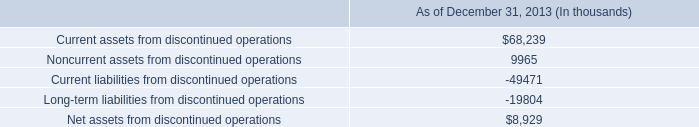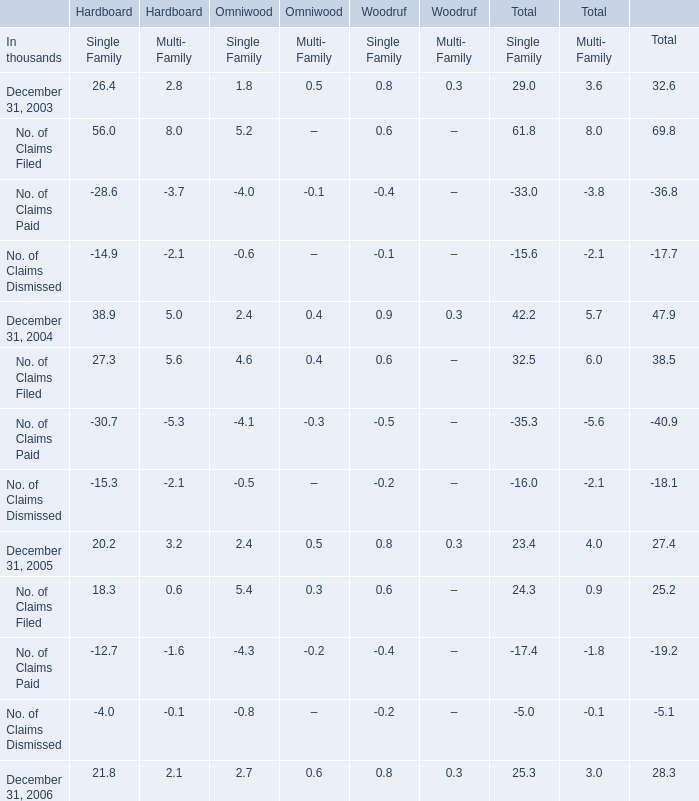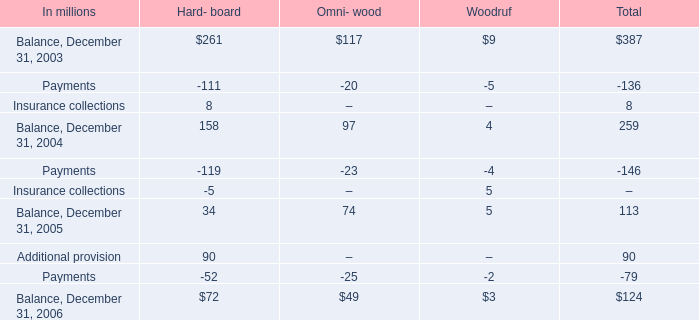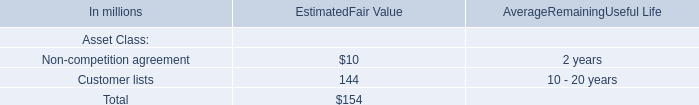What is the growing rate of No. of Claims Filed in the year with the most No. of Claims Dismissed? 
Computations: ((38.5 - 25.2) / 25.2)
Answer: 0.52778. 